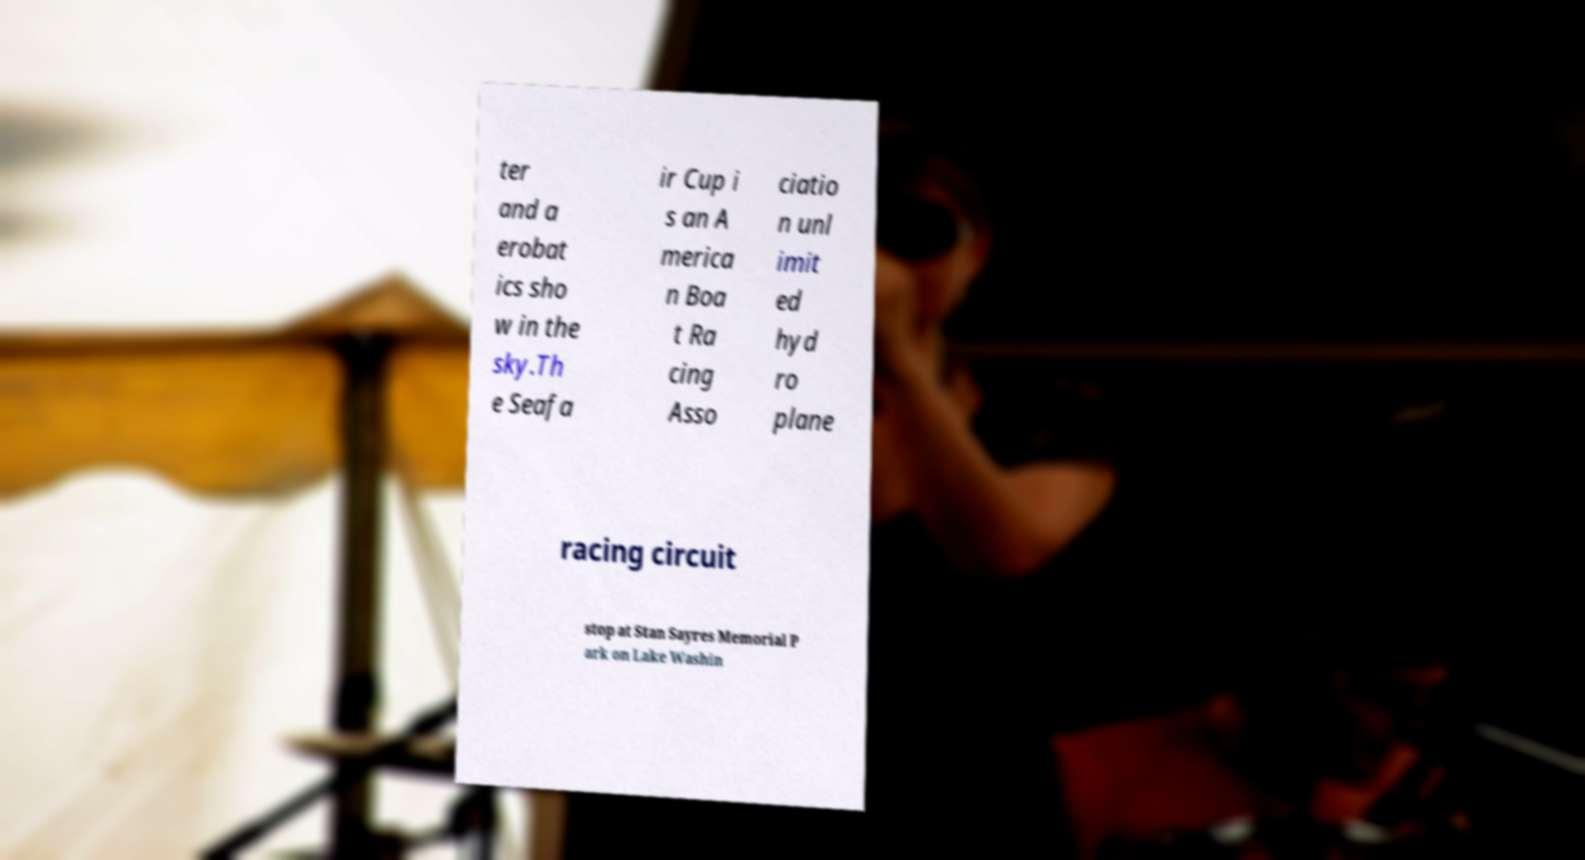Please read and relay the text visible in this image. What does it say? ter and a erobat ics sho w in the sky.Th e Seafa ir Cup i s an A merica n Boa t Ra cing Asso ciatio n unl imit ed hyd ro plane racing circuit stop at Stan Sayres Memorial P ark on Lake Washin 